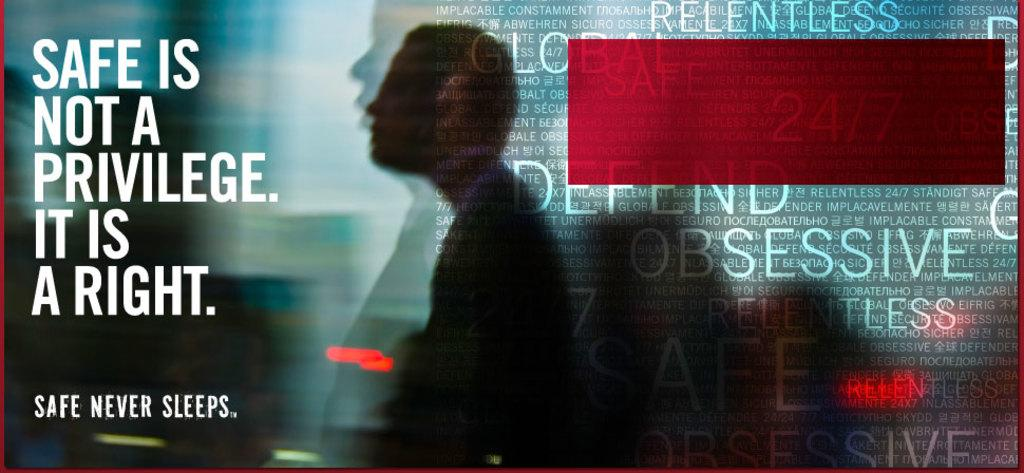What is the main subject of the image? There is a person standing in the image. Can you describe any modifications made to the image? The image has been edited. Are there any words or phrases visible in the image? Yes, there is some text visible in the image. What type of drug is the person holding in the image? There is no drug present in the image; it only shows a person standing. How does the person rub their hands together in the image? The person is not rubbing their hands together in the image; they are simply standing. 